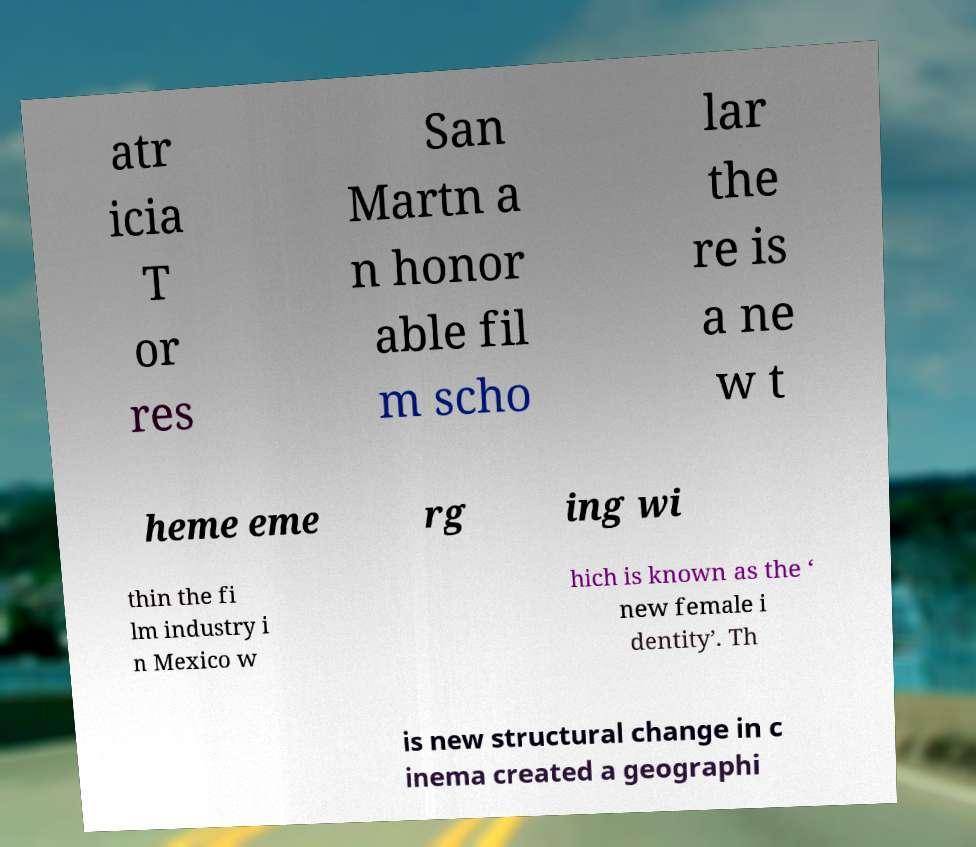Can you read and provide the text displayed in the image?This photo seems to have some interesting text. Can you extract and type it out for me? atr icia T or res San Martn a n honor able fil m scho lar the re is a ne w t heme eme rg ing wi thin the fi lm industry i n Mexico w hich is known as the ‘ new female i dentity’. Th is new structural change in c inema created a geographi 